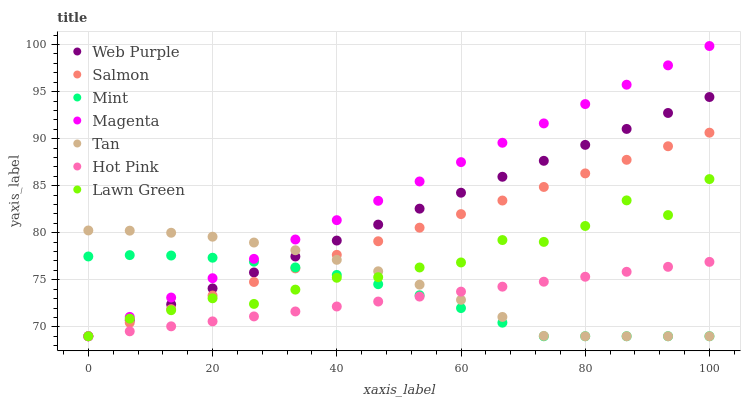Does Hot Pink have the minimum area under the curve?
Answer yes or no. Yes. Does Magenta have the maximum area under the curve?
Answer yes or no. Yes. Does Salmon have the minimum area under the curve?
Answer yes or no. No. Does Salmon have the maximum area under the curve?
Answer yes or no. No. Is Salmon the smoothest?
Answer yes or no. Yes. Is Lawn Green the roughest?
Answer yes or no. Yes. Is Hot Pink the smoothest?
Answer yes or no. No. Is Hot Pink the roughest?
Answer yes or no. No. Does Lawn Green have the lowest value?
Answer yes or no. Yes. Does Magenta have the highest value?
Answer yes or no. Yes. Does Salmon have the highest value?
Answer yes or no. No. Does Lawn Green intersect Magenta?
Answer yes or no. Yes. Is Lawn Green less than Magenta?
Answer yes or no. No. Is Lawn Green greater than Magenta?
Answer yes or no. No. 